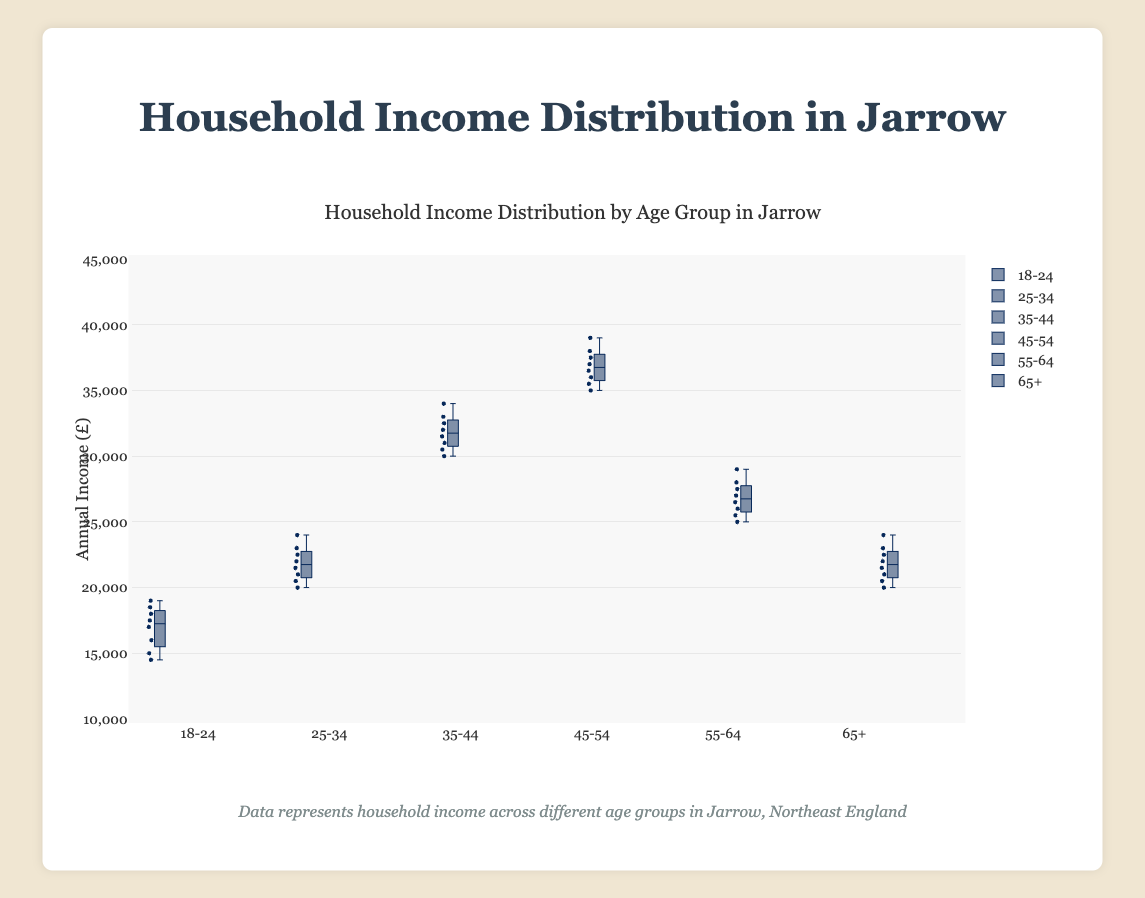How many age groups are presented in the figure? The figure shows income distributions for different age groups. Counting the distinct labels on the x-axis will give the number of age groups.
Answer: 6 Which age group has the highest median household income? Look at the median lines inside the boxes for each age group and identify the one that is highest on the y-axis.
Answer: 45-54 What is the approximate interquartile range (IQR) for the 35-44 age group? For the 35-44 age group box, the IQR is the difference between the upper quartile (top edge of the box) and the lower quartile (bottom edge of the box).
Answer: 5,000 Between which two age groups does the median household income appear to be the same? By comparing the median lines of each age group, identify which have the same y-axis value for the median line.
Answer: 25-34 and 65+ Which age group shows the widest range in household income distribution? The range is given by the distance between the minimum and maximum whiskers of each box plot. Find the widest one.
Answer: 45-54 What is the median income for the 55-64 age group? Locate the line inside the box for the 55-64 age group, which represents the median.
Answer: 27,500 Compare the 25-34 and 55-64 age groups: which has the higher 75th percentile? The 75th percentile is given by the top edge of the box. Compare these edges for the two age groups.
Answer: 25-34 What is the approximate range of household incomes for the 18-24 age group? The range is the difference between the maximum and minimum points reached by the whiskers for the 18-24 age group.
Answer: 4,500 Which age group has the smallest median household income? Identify the box with the median line closest to the bottom of the y-axis.
Answer: 18-24 For the age group 65+, what can you say about the spread of the data points? Explain by looking at the distance between the edges of the box (IQR), whiskers, and any outliers.
Answer: Moderate spread with a somewhat compact IQR and a reasonably wide range 